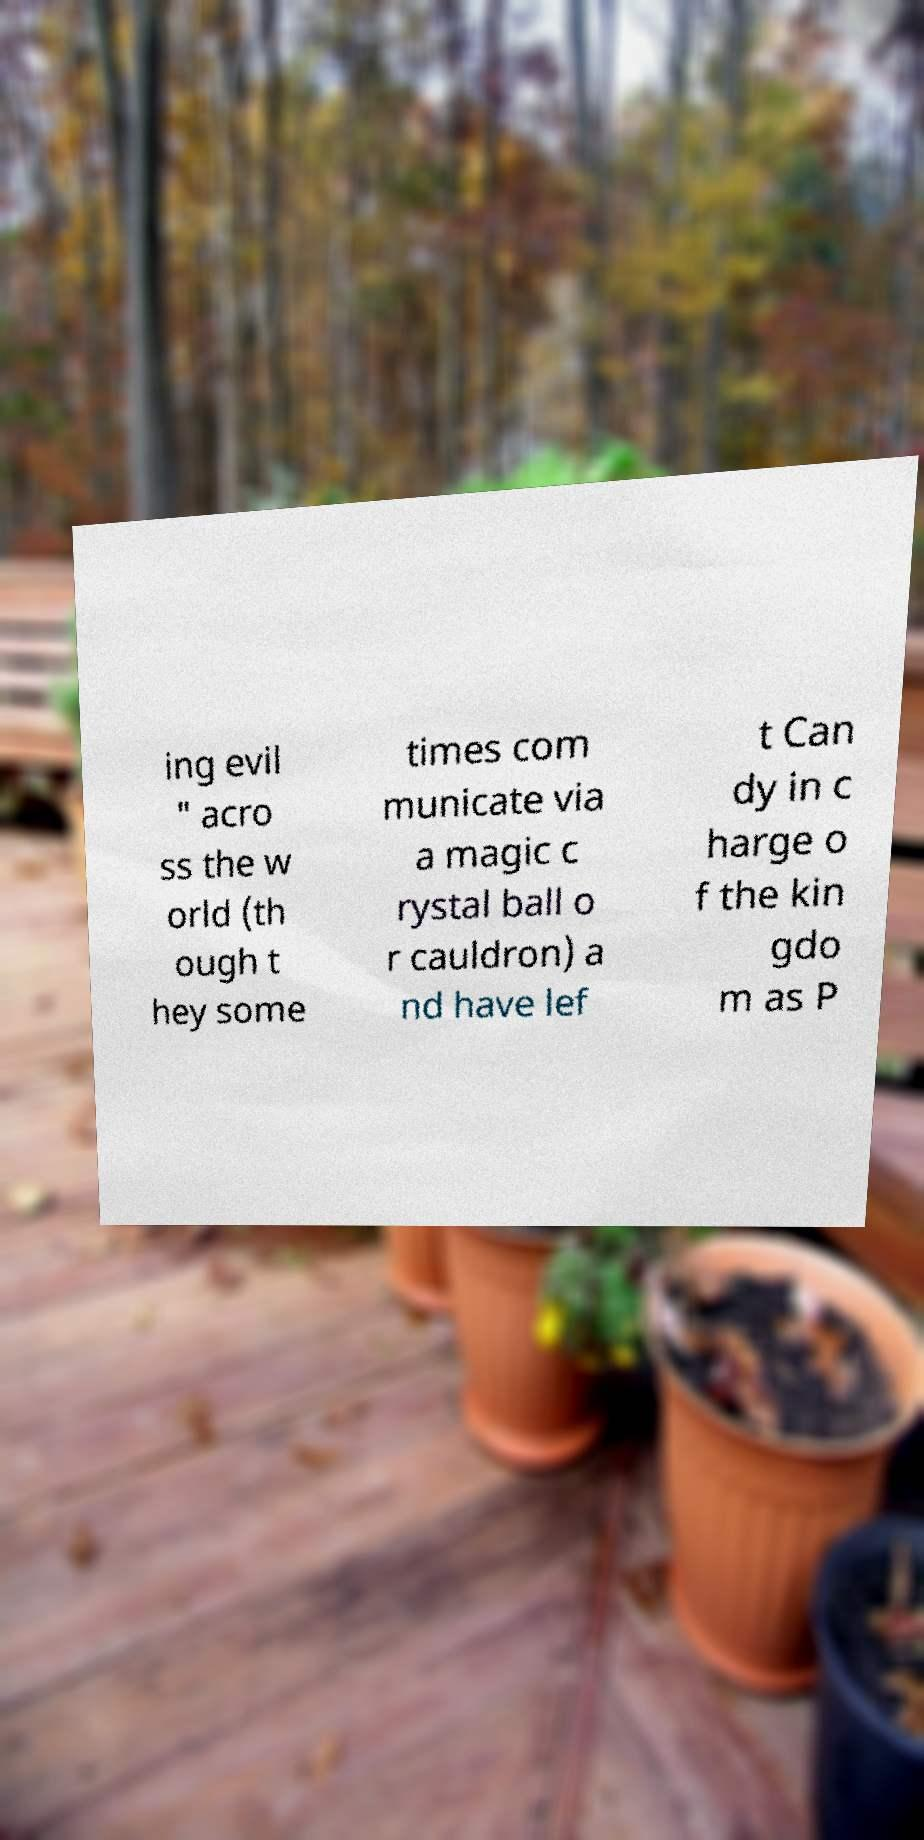There's text embedded in this image that I need extracted. Can you transcribe it verbatim? ing evil " acro ss the w orld (th ough t hey some times com municate via a magic c rystal ball o r cauldron) a nd have lef t Can dy in c harge o f the kin gdo m as P 